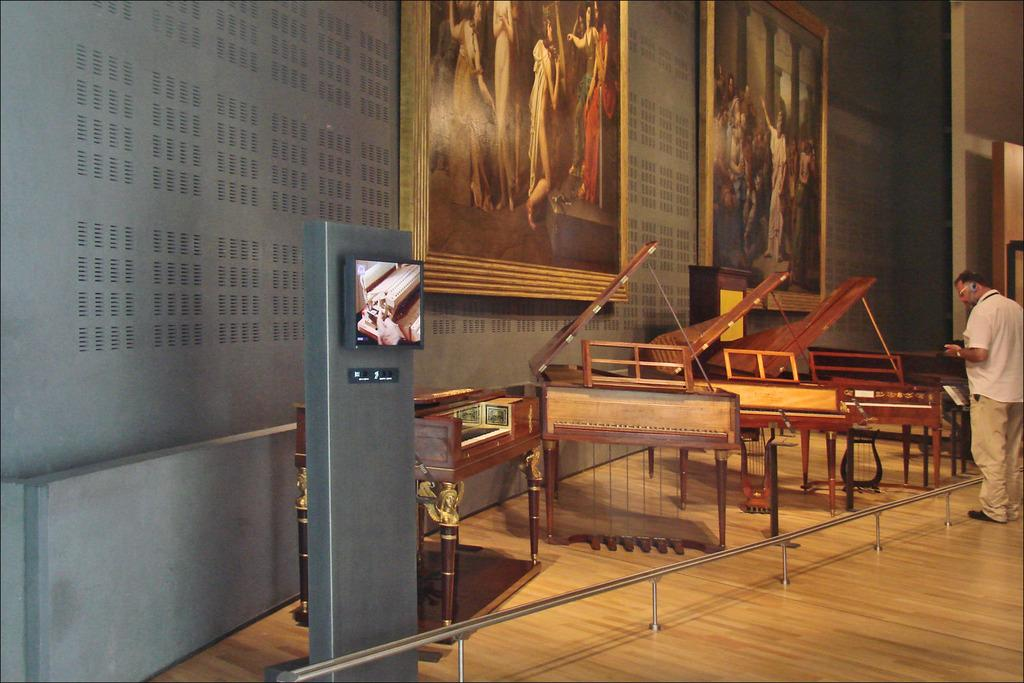What type of musical instruments are present in the image? There are pianos in the image. Can you describe the person standing in the image? There is a man standing on the right side of the image. What can be seen on the wall in the image? There are photo frames fixed to the wall in the image. What type of advertisement can be seen on the pianos in the image? There is no advertisement present on the pianos in the image. Can you describe the carriage that is being pulled by the horses in the image? There are no horses or carriages present in the image. 